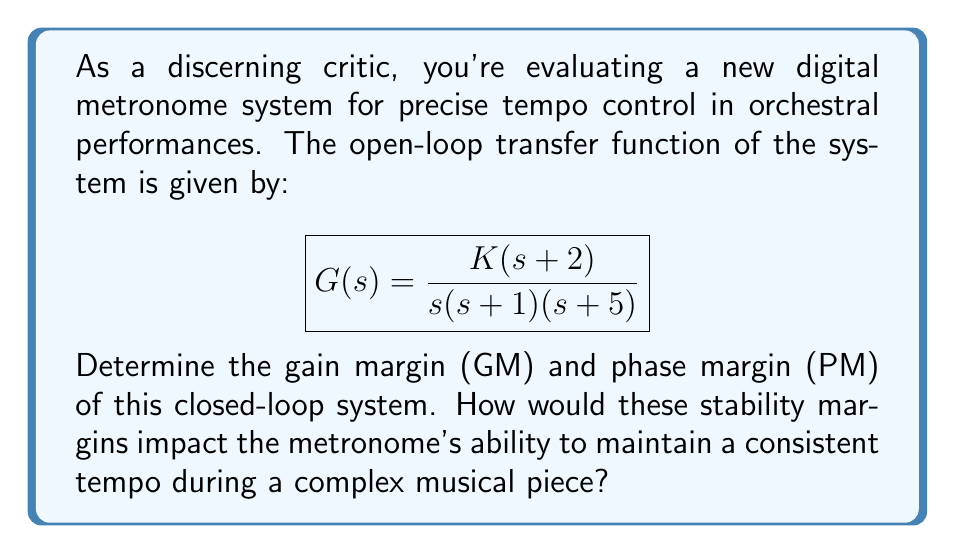Show me your answer to this math problem. To determine the stability margins, we need to analyze the open-loop transfer function using the following steps:

1. Find the crossover frequencies:
   a) Gain crossover frequency ($\omega_{gc}$): where $|G(j\omega)| = 1$ or 0 dB
   b) Phase crossover frequency ($\omega_{pc}$): where $\angle G(j\omega) = -180°$

2. Calculate the gain margin (GM) and phase margin (PM):
   GM = $-20 \log_{10} |G(j\omega_{pc})|$
   PM = $180° + \angle G(j\omega_{gc})$

Let's start by factoring out K from the transfer function:

$$G(s) = K \cdot \frac{(s+2)}{s(s+1)(s+5)}$$

To find the crossover frequencies, we need to analyze the magnitude and phase of G(jω):

$$|G(j\omega)| = K \cdot \frac{\sqrt{\omega^2 + 4}}{\omega\sqrt{(\omega^2 + 1)(\omega^2 + 25)}}$$

$$\angle G(j\omega) = \tan^{-1}(\frac{2}{\omega}) - 90° - \tan^{-1}(\omega) - \tan^{-1}(\frac{\omega}{5})$$

For the phase crossover frequency ($\omega_{pc}$), we solve:

$$-180° = \tan^{-1}(\frac{2}{\omega}) - 90° - \tan^{-1}(\omega) - \tan^{-1}(\frac{\omega}{5})$$

Solving this numerically, we get $\omega_{pc} \approx 3.307$ rad/s.

Now, we can calculate the gain margin:

$$GM = -20 \log_{10} |G(j\omega_{pc})| = -20 \log_{10} (K \cdot 0.0681) = 23.34 - 20 \log_{10}(K)$$

For the gain crossover frequency ($\omega_{gc}$), we solve:

$$1 = K \cdot \frac{\sqrt{\omega^2 + 4}}{\omega\sqrt{(\omega^2 + 1)(\omega^2 + 25)}}$$

This equation depends on K. Let's assume K = 10 for this example. Solving numerically, we get $\omega_{gc} \approx 2.236$ rad/s.

Now we can calculate the phase margin:

$$PM = 180° + \angle G(j\omega_{gc}) \approx 41.8°$$

The stability margins impact the metronome's performance as follows:
1. Gain Margin: A larger GM (> 6 dB) indicates better robustness against gain variations, ensuring consistent tempo even with fluctuations in the system's sensitivity.
2. Phase Margin: A PM between 30° and 60° provides a good balance between system responsiveness and stability, allowing the metronome to adjust quickly to tempo changes without oscillating.
Answer: For K = 10:
Gain Margin (GM) = 3.34 dB
Phase Margin (PM) ≈ 41.8°

These margins suggest a stable system with good robustness and responsiveness, suitable for maintaining consistent tempo during complex musical pieces. 